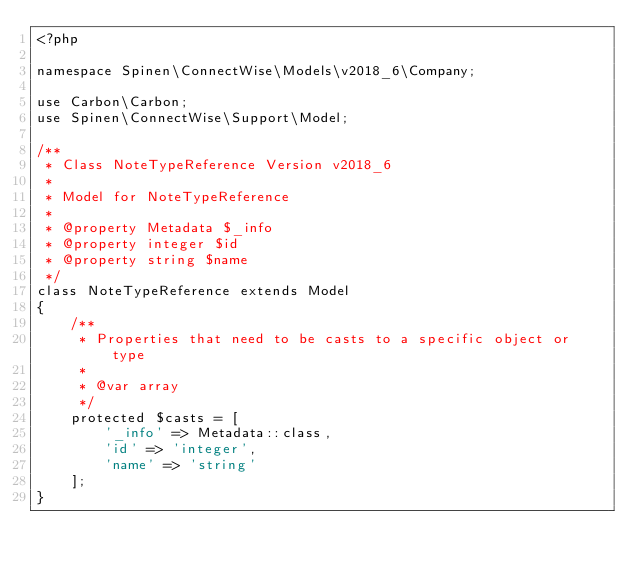<code> <loc_0><loc_0><loc_500><loc_500><_PHP_><?php

namespace Spinen\ConnectWise\Models\v2018_6\Company;

use Carbon\Carbon;
use Spinen\ConnectWise\Support\Model;

/**
 * Class NoteTypeReference Version v2018_6
 *
 * Model for NoteTypeReference
 *
 * @property Metadata $_info
 * @property integer $id
 * @property string $name
 */
class NoteTypeReference extends Model
{
    /**
     * Properties that need to be casts to a specific object or type
     *
     * @var array
     */
    protected $casts = [
        '_info' => Metadata::class,
        'id' => 'integer',
        'name' => 'string'
    ];
}
</code> 